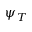Convert formula to latex. <formula><loc_0><loc_0><loc_500><loc_500>\psi _ { T }</formula> 